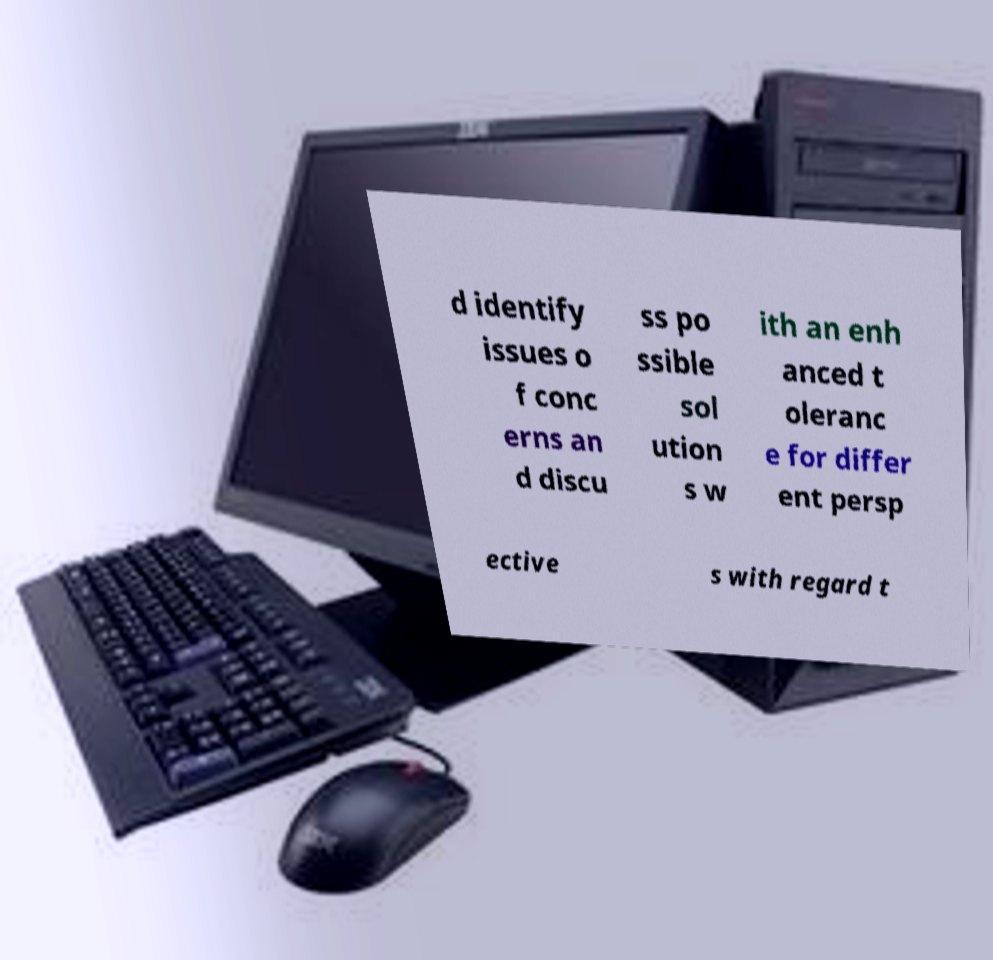There's text embedded in this image that I need extracted. Can you transcribe it verbatim? d identify issues o f conc erns an d discu ss po ssible sol ution s w ith an enh anced t oleranc e for differ ent persp ective s with regard t 